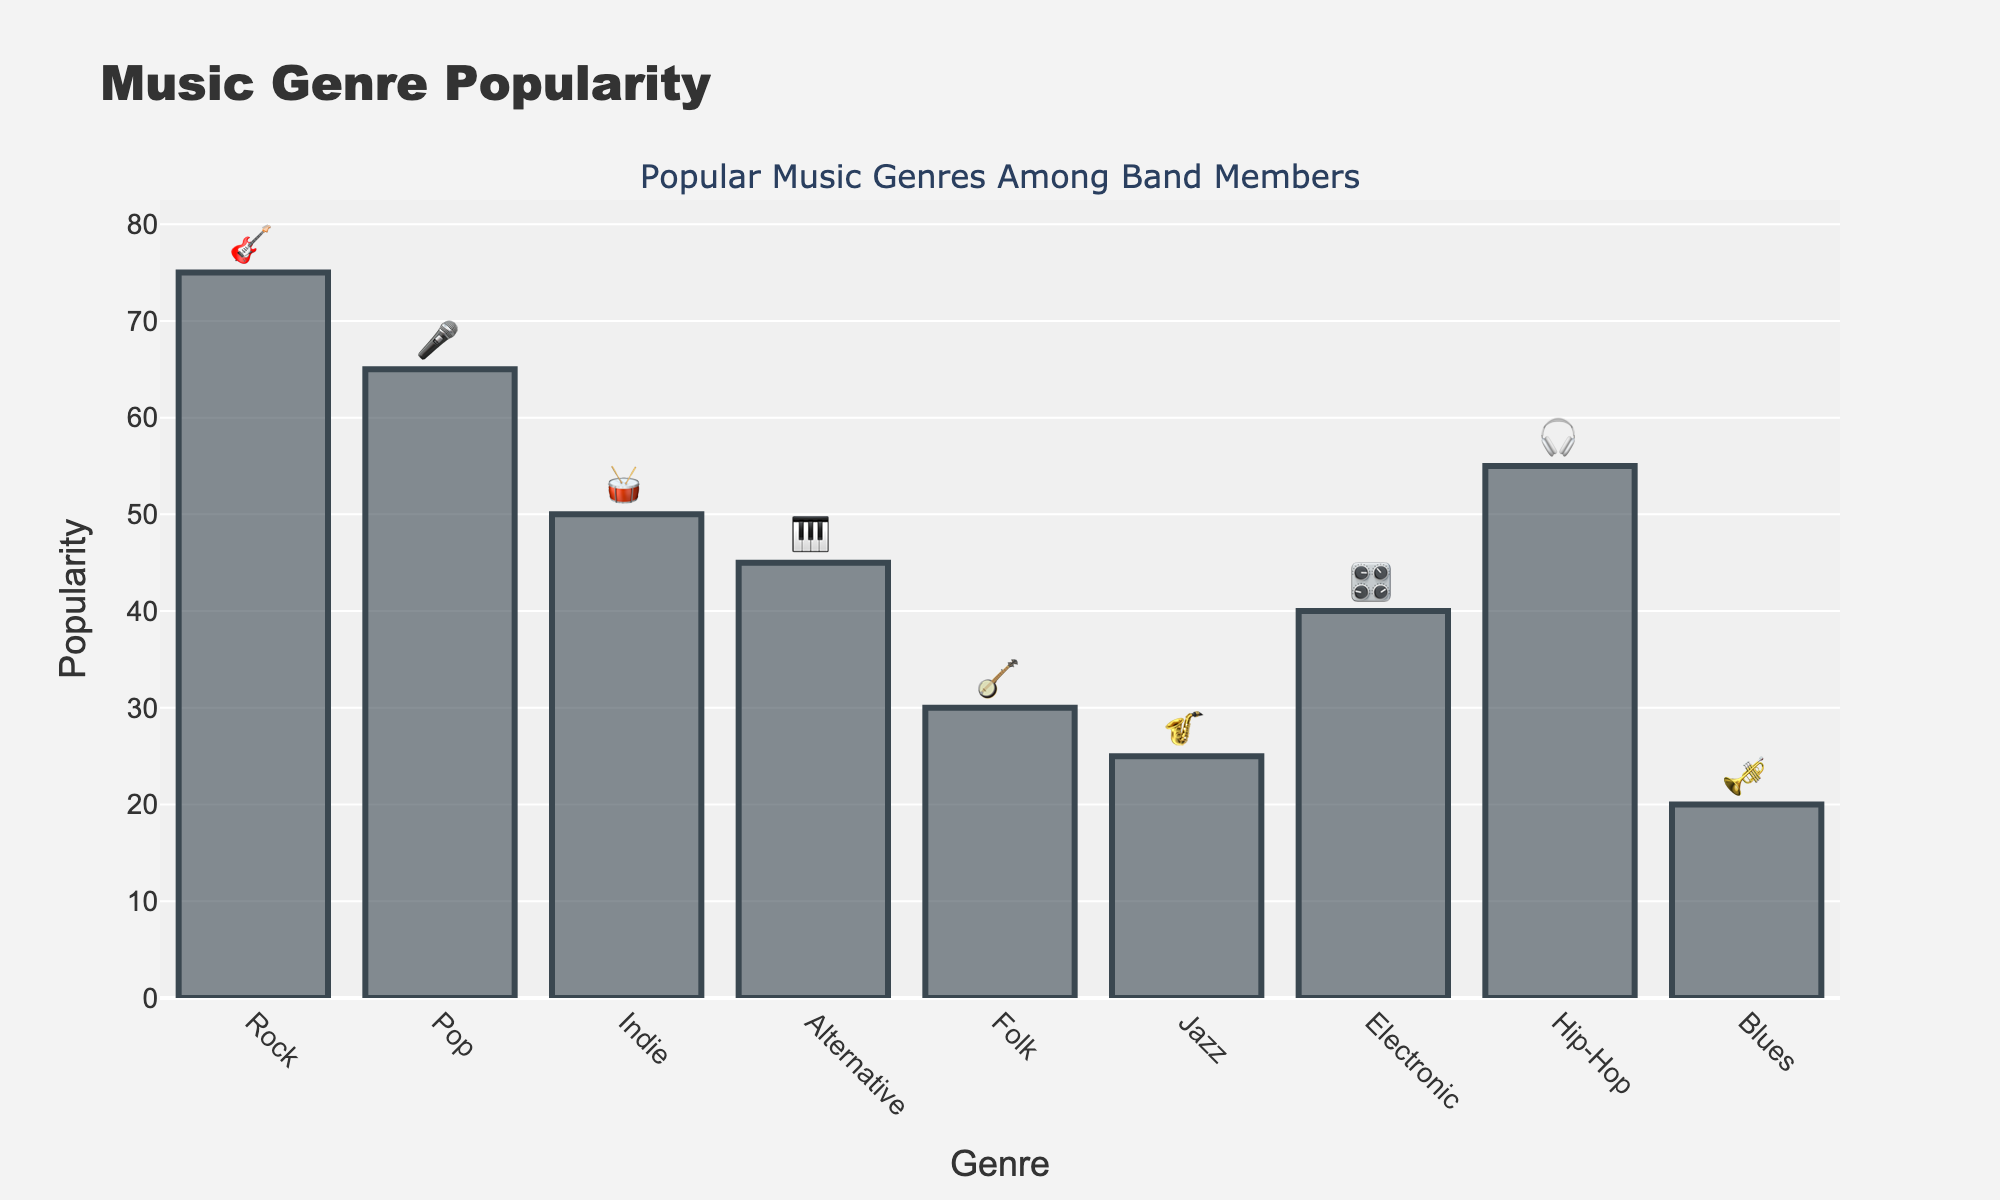What is the title of the chart? The title of the chart is usually displayed prominently at the top of the figure. Here, it states the main topic or purpose of the chart.
Answer: Music Genre Popularity Which genre has the highest popularity? By looking at the bars, find the tallest one. The genre associated with this bar is the one with the highest popularity value.
Answer: Rock What is the instrument emoji for Indie music? Each genre is represented by an instrument emoji displayed at the top of the bar. Locate the 'Indie' bar and identify its corresponding emoji.
Answer: 🥁 How many genres have a popularity greater than 50? Count the number of bars that have heights greater than the 50 mark on the y-axis.
Answer: 4 Which genre is the least popular? Find the shortest bar in the figure. The genre associated with this bar is the least popular.
Answer: Blues What is the average popularity of all the listed genres? Sum up all the popularity values of the genres, then divide by the number of genres to find the average. (75 + 65 + 50 + 45 + 30 + 25 + 40 + 55 + 20) / 9 = 44.4
Answer: 44.4 Are there more genres with popularity above or below the average popularity value? Compare the number of bars above the calculated average (44.4) to those below it. If there are more above, answer 'above', else answer 'below'.
Answer: below Which genres have a popularity lower than 40? Identify the bars that do not reach the 40 mark on the y-axis and note the genres they represent.
Answer: Jazz, Folk, Blues What is the difference in popularity between Rock and Hip-Hop? Subtract the popularity value of Hip-Hop from that of Rock. (75 - 55)
Answer: 20 How many genres have instrument emojis containing a string or wind instrument? Count the genres whose instrument emojis represent string or wind instruments (e.g. 🎸, 🪕, 🎷, 🎺).
Answer: 4 